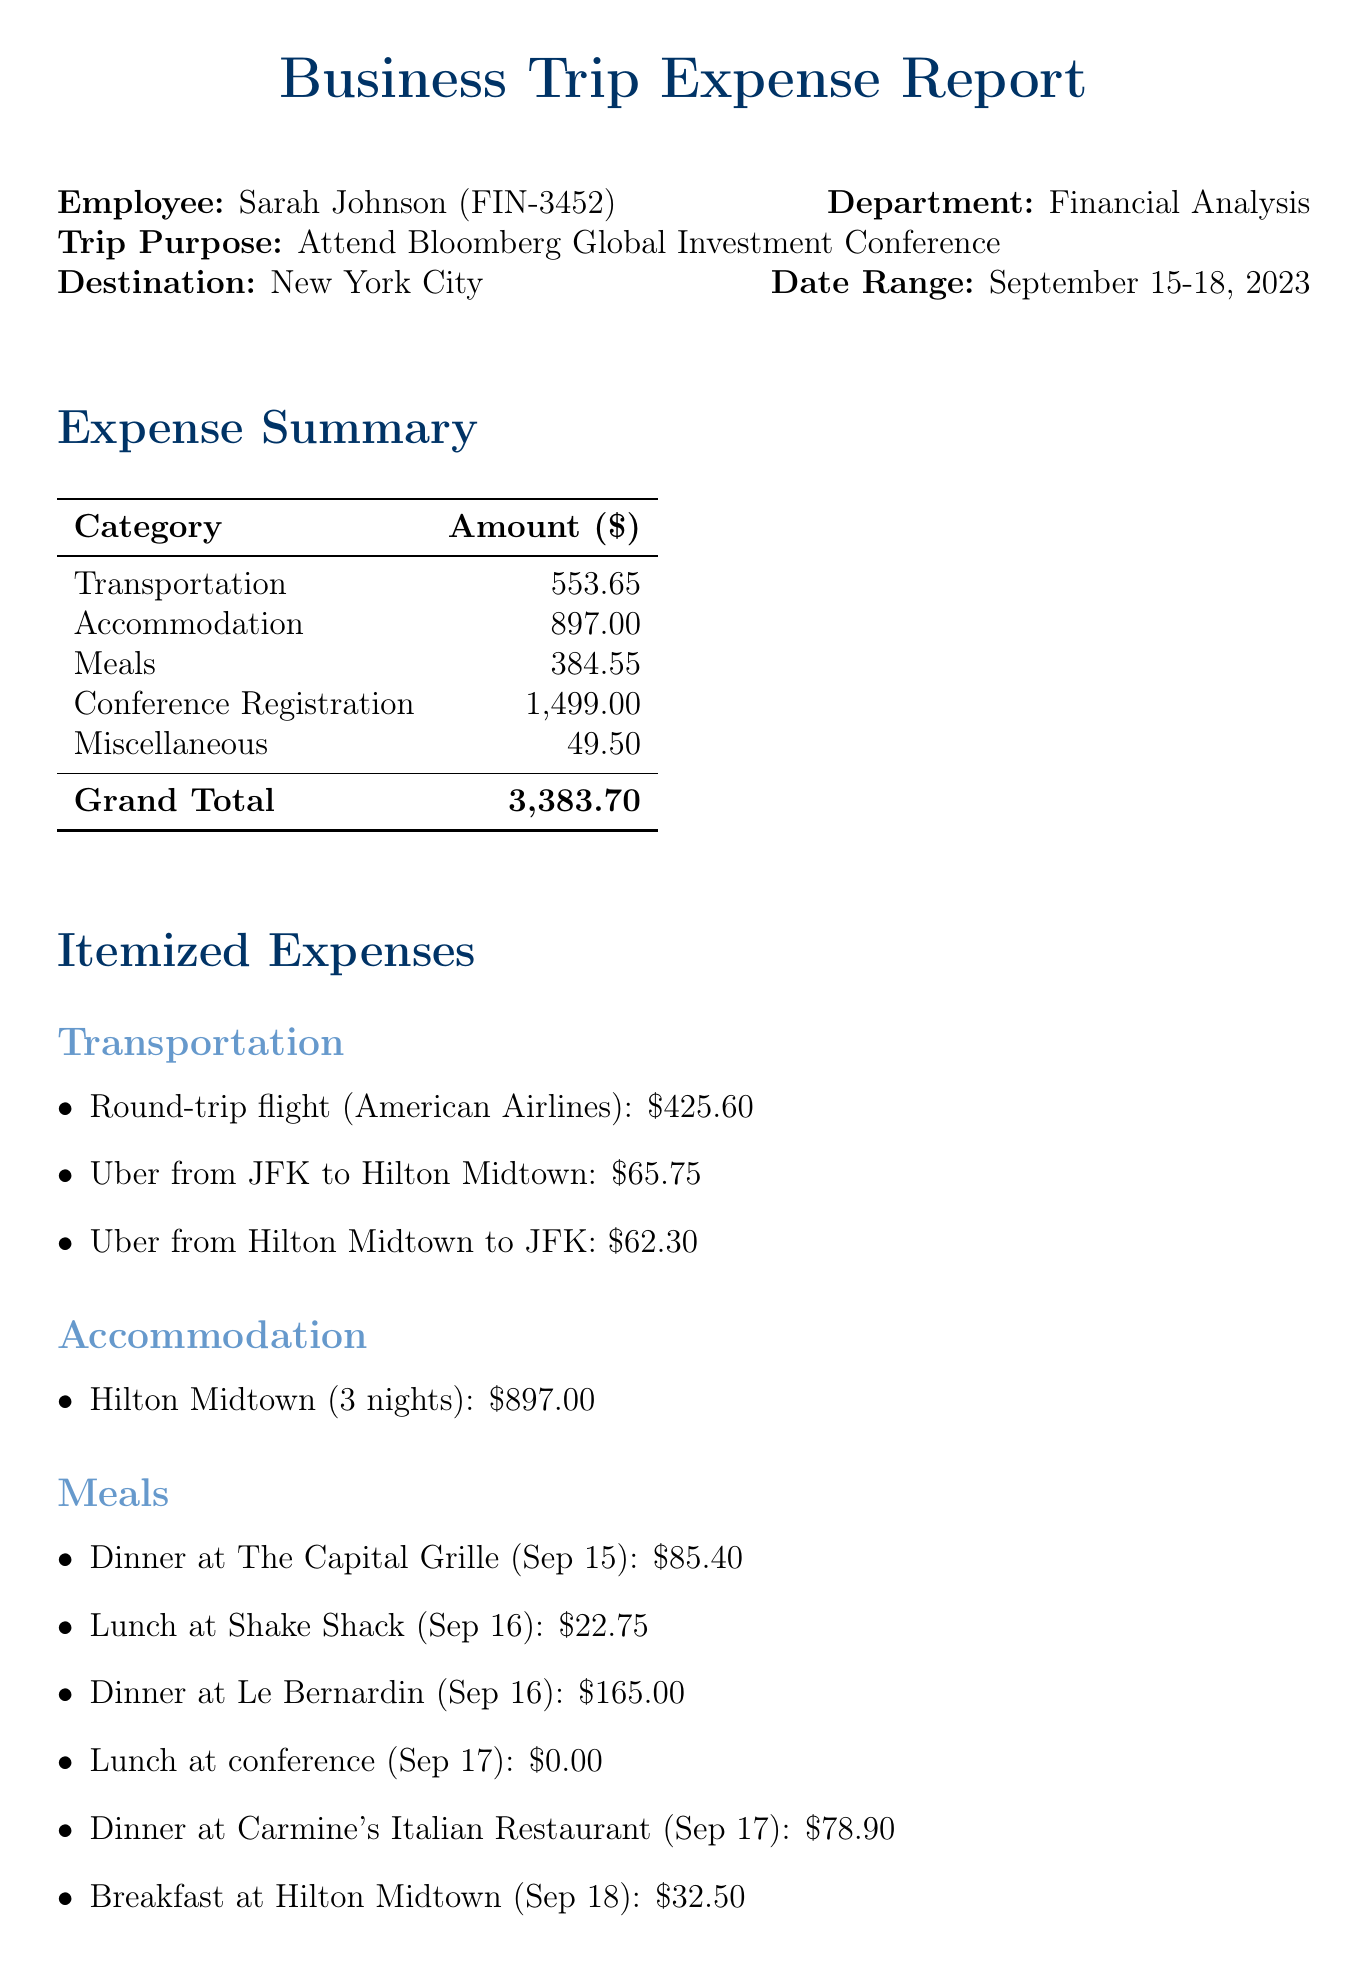what is the total cost of accommodation? The total accommodation cost is detailed in the expense summary as 897.00.
Answer: 897.00 who is the employee that attended the conference? The employee's name is stated at the beginning of the document as Sarah Johnson.
Answer: Sarah Johnson what were the dates of the business trip? The date range for the trip is specified in the trip details section as September 15-18, 2023.
Answer: September 15-18, 2023 how much did Sarah spend on meals? The total meals expenditure is mentioned in the expense summary, totaling 384.55.
Answer: 384.55 what transportation expense is the highest? The highest transportation expense is for the round-trip flight (American Airlines), which costs 425.60.
Answer: Round-trip flight (American Airlines) what is the grand total of all expenses? The grand total is provided in the expense summary as a cumulative amount of all expenses: 3383.70.
Answer: 3,383.70 which dining location had the highest cost? The most expensive meal was dinner at Le Bernardin on September 16, which cost 165.00.
Answer: Dinner at Le Bernardin who approved the expense report? The manager who approved the report is Michael Chen, as indicated in the approval section.
Answer: Michael Chen what was one of the additional notes mentioned in the report? One of the notes states that all expenses are within company policy limits, highlighting compliance.
Answer: All expenses are within company policy limits 